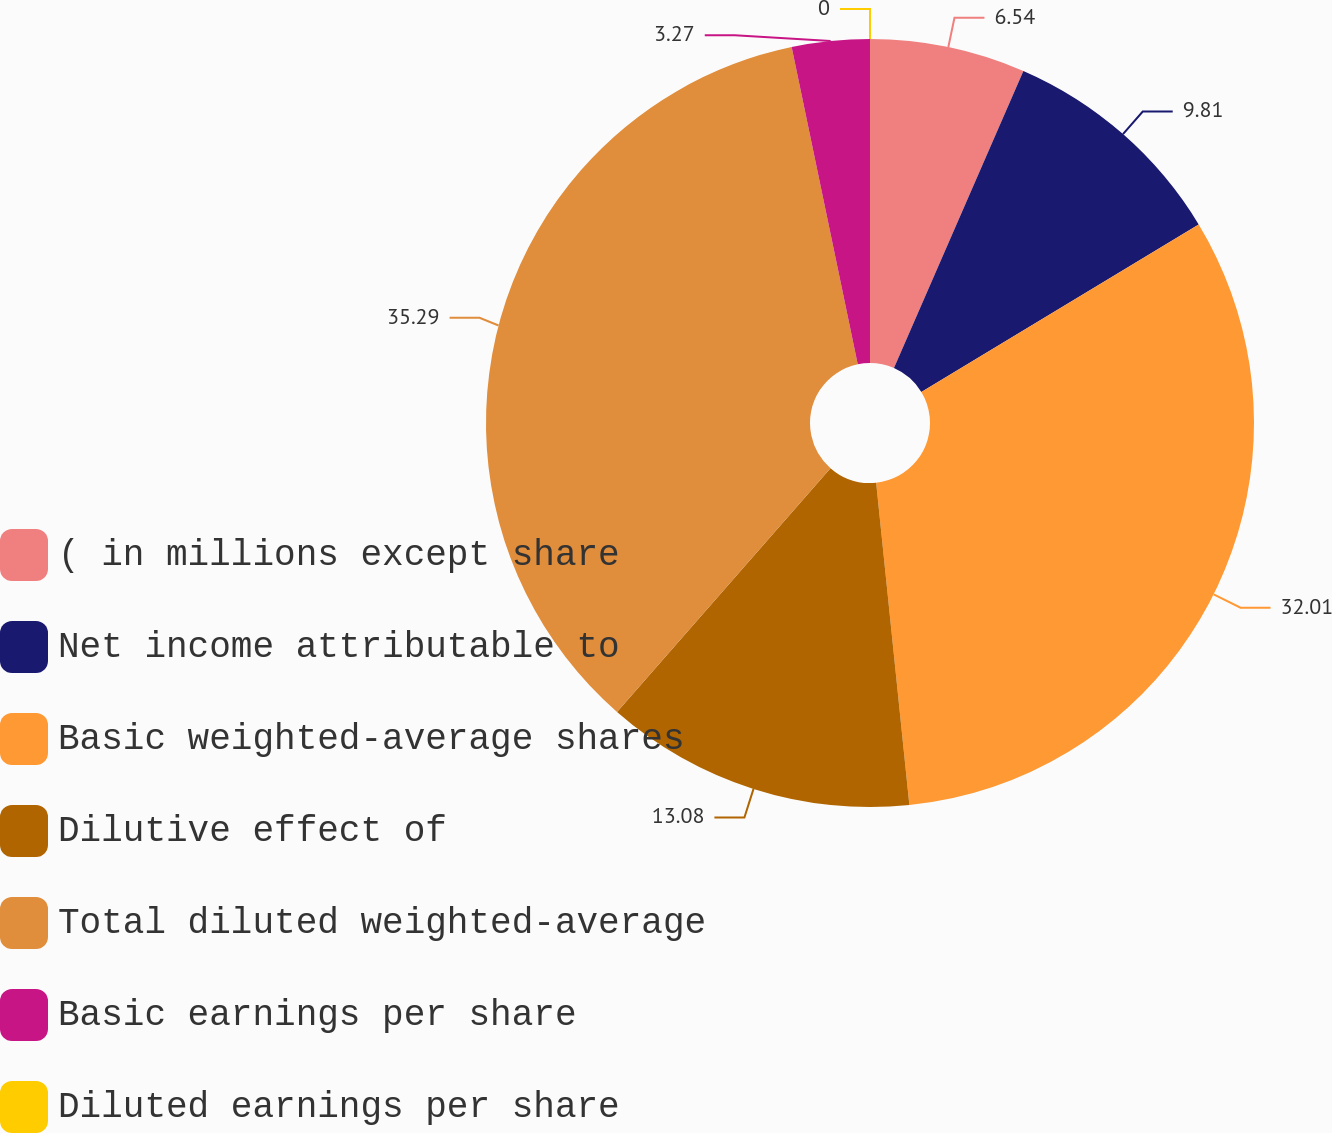Convert chart to OTSL. <chart><loc_0><loc_0><loc_500><loc_500><pie_chart><fcel>( in millions except share<fcel>Net income attributable to<fcel>Basic weighted-average shares<fcel>Dilutive effect of<fcel>Total diluted weighted-average<fcel>Basic earnings per share<fcel>Diluted earnings per share<nl><fcel>6.54%<fcel>9.81%<fcel>32.01%<fcel>13.08%<fcel>35.28%<fcel>3.27%<fcel>0.0%<nl></chart> 